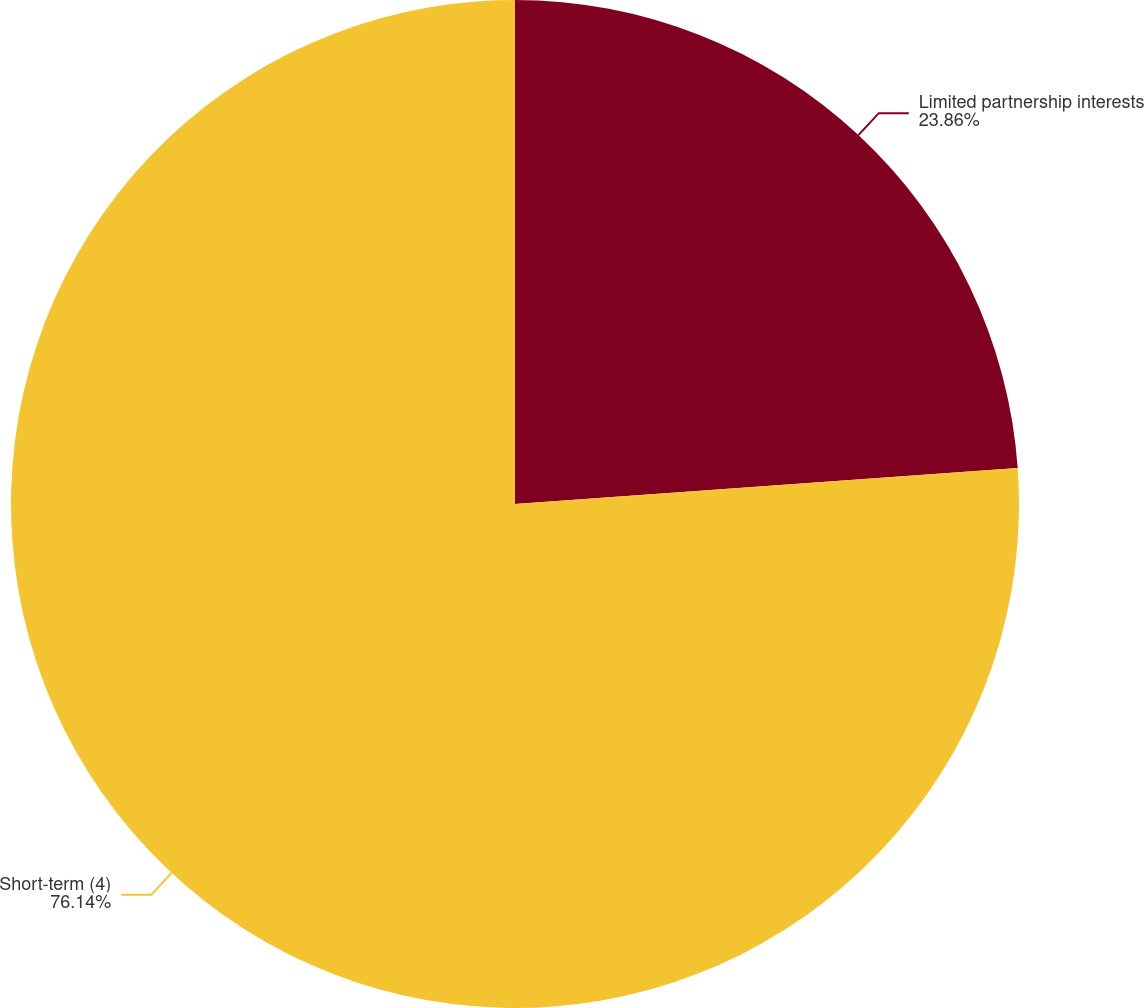Convert chart to OTSL. <chart><loc_0><loc_0><loc_500><loc_500><pie_chart><fcel>Limited partnership interests<fcel>Short-term (4)<nl><fcel>23.86%<fcel>76.14%<nl></chart> 